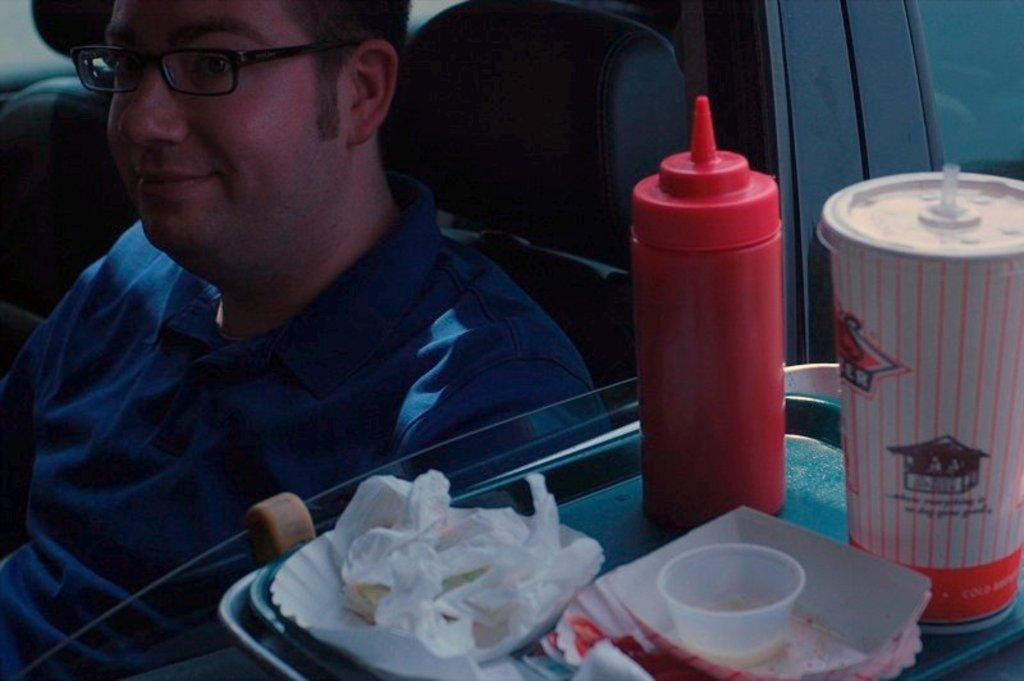What objects are in the foreground of the image? There are bottles, plates, a bowl, and papers in a tray in the foreground of the image. What can be seen in the background of the image? There is a person sitting on a chair in the background of the image. Can you describe the lighting in the image? The image may have been taken during the night, which suggests that the lighting is dim or artificial. What type of whistle is being used by the government in the image? There is no whistle or reference to the government present in the image. 